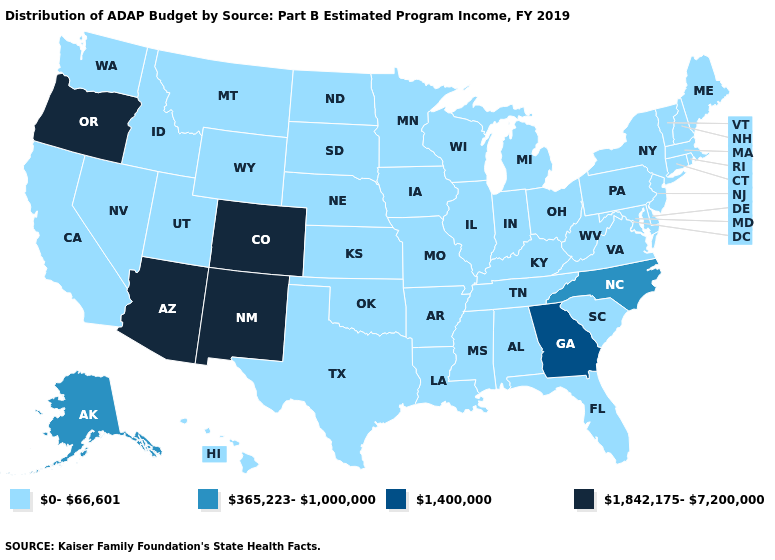Which states have the lowest value in the USA?
Answer briefly. Alabama, Arkansas, California, Connecticut, Delaware, Florida, Hawaii, Idaho, Illinois, Indiana, Iowa, Kansas, Kentucky, Louisiana, Maine, Maryland, Massachusetts, Michigan, Minnesota, Mississippi, Missouri, Montana, Nebraska, Nevada, New Hampshire, New Jersey, New York, North Dakota, Ohio, Oklahoma, Pennsylvania, Rhode Island, South Carolina, South Dakota, Tennessee, Texas, Utah, Vermont, Virginia, Washington, West Virginia, Wisconsin, Wyoming. What is the lowest value in states that border Nevada?
Answer briefly. 0-66,601. Among the states that border Utah , does Idaho have the highest value?
Concise answer only. No. What is the highest value in states that border North Carolina?
Give a very brief answer. 1,400,000. Is the legend a continuous bar?
Concise answer only. No. Which states have the lowest value in the Northeast?
Concise answer only. Connecticut, Maine, Massachusetts, New Hampshire, New Jersey, New York, Pennsylvania, Rhode Island, Vermont. Among the states that border South Carolina , which have the lowest value?
Concise answer only. North Carolina. Name the states that have a value in the range 365,223-1,000,000?
Write a very short answer. Alaska, North Carolina. Name the states that have a value in the range 1,842,175-7,200,000?
Write a very short answer. Arizona, Colorado, New Mexico, Oregon. Name the states that have a value in the range 1,842,175-7,200,000?
Write a very short answer. Arizona, Colorado, New Mexico, Oregon. What is the highest value in states that border Alabama?
Answer briefly. 1,400,000. Among the states that border Oregon , which have the lowest value?
Quick response, please. California, Idaho, Nevada, Washington. What is the value of Montana?
Give a very brief answer. 0-66,601. 